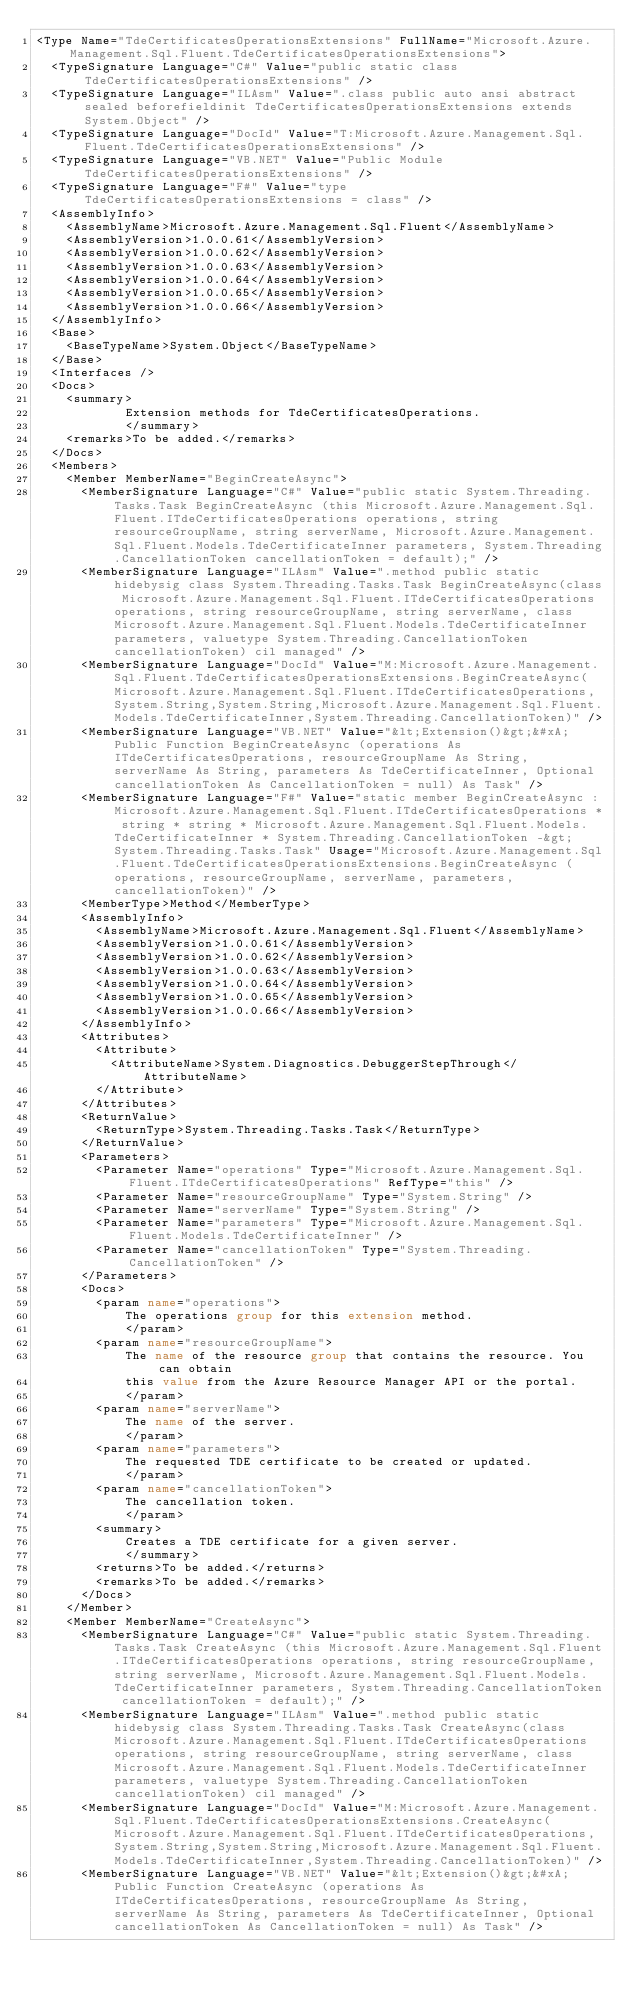<code> <loc_0><loc_0><loc_500><loc_500><_XML_><Type Name="TdeCertificatesOperationsExtensions" FullName="Microsoft.Azure.Management.Sql.Fluent.TdeCertificatesOperationsExtensions">
  <TypeSignature Language="C#" Value="public static class TdeCertificatesOperationsExtensions" />
  <TypeSignature Language="ILAsm" Value=".class public auto ansi abstract sealed beforefieldinit TdeCertificatesOperationsExtensions extends System.Object" />
  <TypeSignature Language="DocId" Value="T:Microsoft.Azure.Management.Sql.Fluent.TdeCertificatesOperationsExtensions" />
  <TypeSignature Language="VB.NET" Value="Public Module TdeCertificatesOperationsExtensions" />
  <TypeSignature Language="F#" Value="type TdeCertificatesOperationsExtensions = class" />
  <AssemblyInfo>
    <AssemblyName>Microsoft.Azure.Management.Sql.Fluent</AssemblyName>
    <AssemblyVersion>1.0.0.61</AssemblyVersion>
    <AssemblyVersion>1.0.0.62</AssemblyVersion>
    <AssemblyVersion>1.0.0.63</AssemblyVersion>
    <AssemblyVersion>1.0.0.64</AssemblyVersion>
    <AssemblyVersion>1.0.0.65</AssemblyVersion>
    <AssemblyVersion>1.0.0.66</AssemblyVersion>
  </AssemblyInfo>
  <Base>
    <BaseTypeName>System.Object</BaseTypeName>
  </Base>
  <Interfaces />
  <Docs>
    <summary>
            Extension methods for TdeCertificatesOperations.
            </summary>
    <remarks>To be added.</remarks>
  </Docs>
  <Members>
    <Member MemberName="BeginCreateAsync">
      <MemberSignature Language="C#" Value="public static System.Threading.Tasks.Task BeginCreateAsync (this Microsoft.Azure.Management.Sql.Fluent.ITdeCertificatesOperations operations, string resourceGroupName, string serverName, Microsoft.Azure.Management.Sql.Fluent.Models.TdeCertificateInner parameters, System.Threading.CancellationToken cancellationToken = default);" />
      <MemberSignature Language="ILAsm" Value=".method public static hidebysig class System.Threading.Tasks.Task BeginCreateAsync(class Microsoft.Azure.Management.Sql.Fluent.ITdeCertificatesOperations operations, string resourceGroupName, string serverName, class Microsoft.Azure.Management.Sql.Fluent.Models.TdeCertificateInner parameters, valuetype System.Threading.CancellationToken cancellationToken) cil managed" />
      <MemberSignature Language="DocId" Value="M:Microsoft.Azure.Management.Sql.Fluent.TdeCertificatesOperationsExtensions.BeginCreateAsync(Microsoft.Azure.Management.Sql.Fluent.ITdeCertificatesOperations,System.String,System.String,Microsoft.Azure.Management.Sql.Fluent.Models.TdeCertificateInner,System.Threading.CancellationToken)" />
      <MemberSignature Language="VB.NET" Value="&lt;Extension()&gt;&#xA;Public Function BeginCreateAsync (operations As ITdeCertificatesOperations, resourceGroupName As String, serverName As String, parameters As TdeCertificateInner, Optional cancellationToken As CancellationToken = null) As Task" />
      <MemberSignature Language="F#" Value="static member BeginCreateAsync : Microsoft.Azure.Management.Sql.Fluent.ITdeCertificatesOperations * string * string * Microsoft.Azure.Management.Sql.Fluent.Models.TdeCertificateInner * System.Threading.CancellationToken -&gt; System.Threading.Tasks.Task" Usage="Microsoft.Azure.Management.Sql.Fluent.TdeCertificatesOperationsExtensions.BeginCreateAsync (operations, resourceGroupName, serverName, parameters, cancellationToken)" />
      <MemberType>Method</MemberType>
      <AssemblyInfo>
        <AssemblyName>Microsoft.Azure.Management.Sql.Fluent</AssemblyName>
        <AssemblyVersion>1.0.0.61</AssemblyVersion>
        <AssemblyVersion>1.0.0.62</AssemblyVersion>
        <AssemblyVersion>1.0.0.63</AssemblyVersion>
        <AssemblyVersion>1.0.0.64</AssemblyVersion>
        <AssemblyVersion>1.0.0.65</AssemblyVersion>
        <AssemblyVersion>1.0.0.66</AssemblyVersion>
      </AssemblyInfo>
      <Attributes>
        <Attribute>
          <AttributeName>System.Diagnostics.DebuggerStepThrough</AttributeName>
        </Attribute>
      </Attributes>
      <ReturnValue>
        <ReturnType>System.Threading.Tasks.Task</ReturnType>
      </ReturnValue>
      <Parameters>
        <Parameter Name="operations" Type="Microsoft.Azure.Management.Sql.Fluent.ITdeCertificatesOperations" RefType="this" />
        <Parameter Name="resourceGroupName" Type="System.String" />
        <Parameter Name="serverName" Type="System.String" />
        <Parameter Name="parameters" Type="Microsoft.Azure.Management.Sql.Fluent.Models.TdeCertificateInner" />
        <Parameter Name="cancellationToken" Type="System.Threading.CancellationToken" />
      </Parameters>
      <Docs>
        <param name="operations">
            The operations group for this extension method.
            </param>
        <param name="resourceGroupName">
            The name of the resource group that contains the resource. You can obtain
            this value from the Azure Resource Manager API or the portal.
            </param>
        <param name="serverName">
            The name of the server.
            </param>
        <param name="parameters">
            The requested TDE certificate to be created or updated.
            </param>
        <param name="cancellationToken">
            The cancellation token.
            </param>
        <summary>
            Creates a TDE certificate for a given server.
            </summary>
        <returns>To be added.</returns>
        <remarks>To be added.</remarks>
      </Docs>
    </Member>
    <Member MemberName="CreateAsync">
      <MemberSignature Language="C#" Value="public static System.Threading.Tasks.Task CreateAsync (this Microsoft.Azure.Management.Sql.Fluent.ITdeCertificatesOperations operations, string resourceGroupName, string serverName, Microsoft.Azure.Management.Sql.Fluent.Models.TdeCertificateInner parameters, System.Threading.CancellationToken cancellationToken = default);" />
      <MemberSignature Language="ILAsm" Value=".method public static hidebysig class System.Threading.Tasks.Task CreateAsync(class Microsoft.Azure.Management.Sql.Fluent.ITdeCertificatesOperations operations, string resourceGroupName, string serverName, class Microsoft.Azure.Management.Sql.Fluent.Models.TdeCertificateInner parameters, valuetype System.Threading.CancellationToken cancellationToken) cil managed" />
      <MemberSignature Language="DocId" Value="M:Microsoft.Azure.Management.Sql.Fluent.TdeCertificatesOperationsExtensions.CreateAsync(Microsoft.Azure.Management.Sql.Fluent.ITdeCertificatesOperations,System.String,System.String,Microsoft.Azure.Management.Sql.Fluent.Models.TdeCertificateInner,System.Threading.CancellationToken)" />
      <MemberSignature Language="VB.NET" Value="&lt;Extension()&gt;&#xA;Public Function CreateAsync (operations As ITdeCertificatesOperations, resourceGroupName As String, serverName As String, parameters As TdeCertificateInner, Optional cancellationToken As CancellationToken = null) As Task" /></code> 